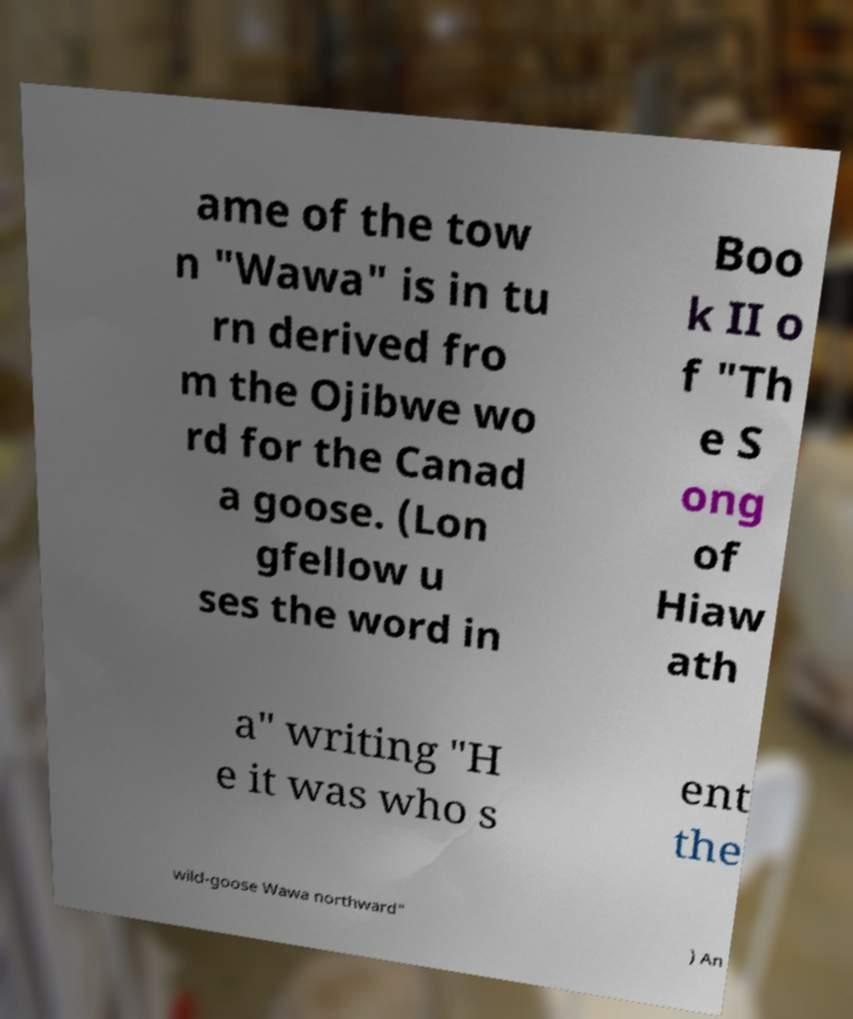What messages or text are displayed in this image? I need them in a readable, typed format. ame of the tow n "Wawa" is in tu rn derived fro m the Ojibwe wo rd for the Canad a goose. (Lon gfellow u ses the word in Boo k II o f "Th e S ong of Hiaw ath a" writing "H e it was who s ent the wild-goose Wawa northward" ) An 